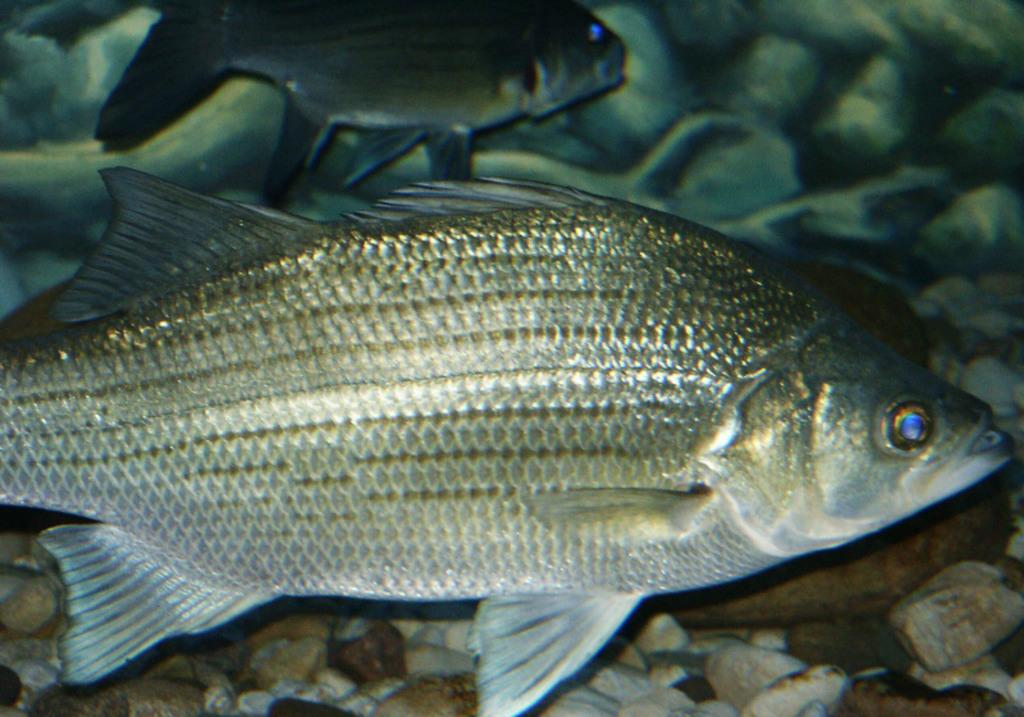What type of animals can be seen in the image? There are fishes in the image. What other objects can be seen in the image? There are stones visible in the image. Where are the fishes and stones located? The fishes and stones are in an aquarium. Can you tell me how many firemen are present in the image? There are no firemen present in the image; it features fishes and stones in an aquarium. What type of creature is shown laughing in the image? There is no creature shown laughing in the image; it only features fishes and stones in an aquarium. 